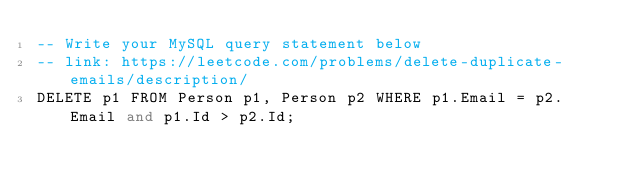Convert code to text. <code><loc_0><loc_0><loc_500><loc_500><_SQL_>-- Write your MySQL query statement below
-- link: https://leetcode.com/problems/delete-duplicate-emails/description/
DELETE p1 FROM Person p1, Person p2 WHERE p1.Email = p2.Email and p1.Id > p2.Id;
</code> 